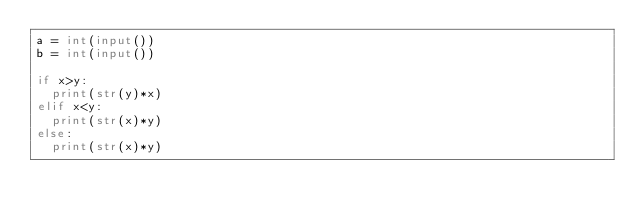<code> <loc_0><loc_0><loc_500><loc_500><_Python_>a = int(input())
b = int(input())

if x>y:
  print(str(y)*x)
elif x<y:
  print(str(x)*y)
else:
  print(str(x)*y)</code> 